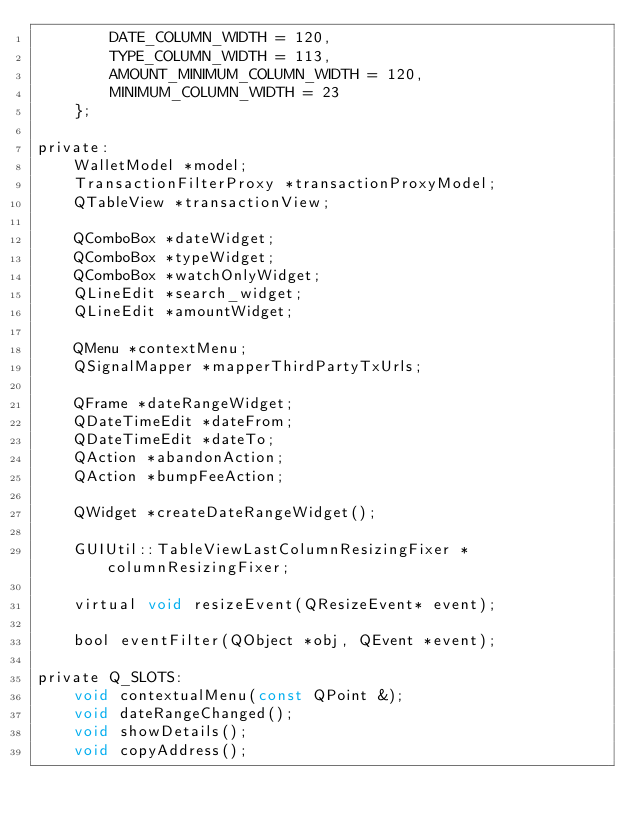<code> <loc_0><loc_0><loc_500><loc_500><_C_>        DATE_COLUMN_WIDTH = 120,
        TYPE_COLUMN_WIDTH = 113,
        AMOUNT_MINIMUM_COLUMN_WIDTH = 120,
        MINIMUM_COLUMN_WIDTH = 23
    };

private:
    WalletModel *model;
    TransactionFilterProxy *transactionProxyModel;
    QTableView *transactionView;

    QComboBox *dateWidget;
    QComboBox *typeWidget;
    QComboBox *watchOnlyWidget;
    QLineEdit *search_widget;
    QLineEdit *amountWidget;

    QMenu *contextMenu;
    QSignalMapper *mapperThirdPartyTxUrls;

    QFrame *dateRangeWidget;
    QDateTimeEdit *dateFrom;
    QDateTimeEdit *dateTo;
    QAction *abandonAction;
    QAction *bumpFeeAction;

    QWidget *createDateRangeWidget();

    GUIUtil::TableViewLastColumnResizingFixer *columnResizingFixer;

    virtual void resizeEvent(QResizeEvent* event);

    bool eventFilter(QObject *obj, QEvent *event);

private Q_SLOTS:
    void contextualMenu(const QPoint &);
    void dateRangeChanged();
    void showDetails();
    void copyAddress();</code> 